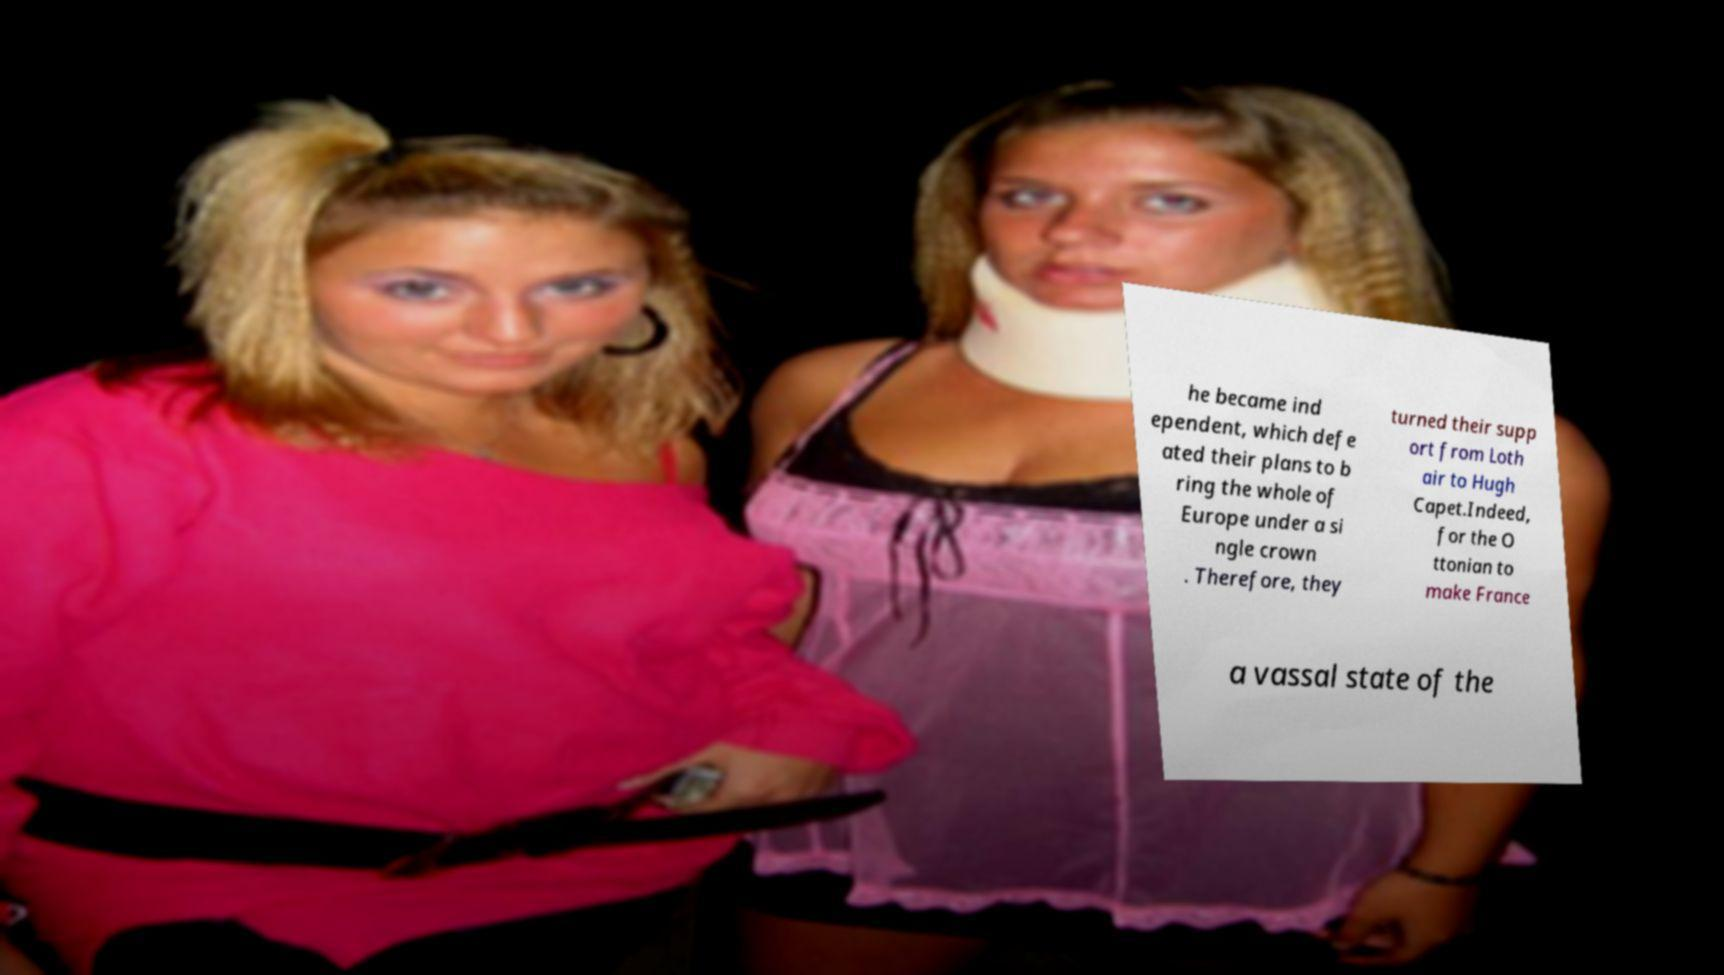What messages or text are displayed in this image? I need them in a readable, typed format. he became ind ependent, which defe ated their plans to b ring the whole of Europe under a si ngle crown . Therefore, they turned their supp ort from Loth air to Hugh Capet.Indeed, for the O ttonian to make France a vassal state of the 